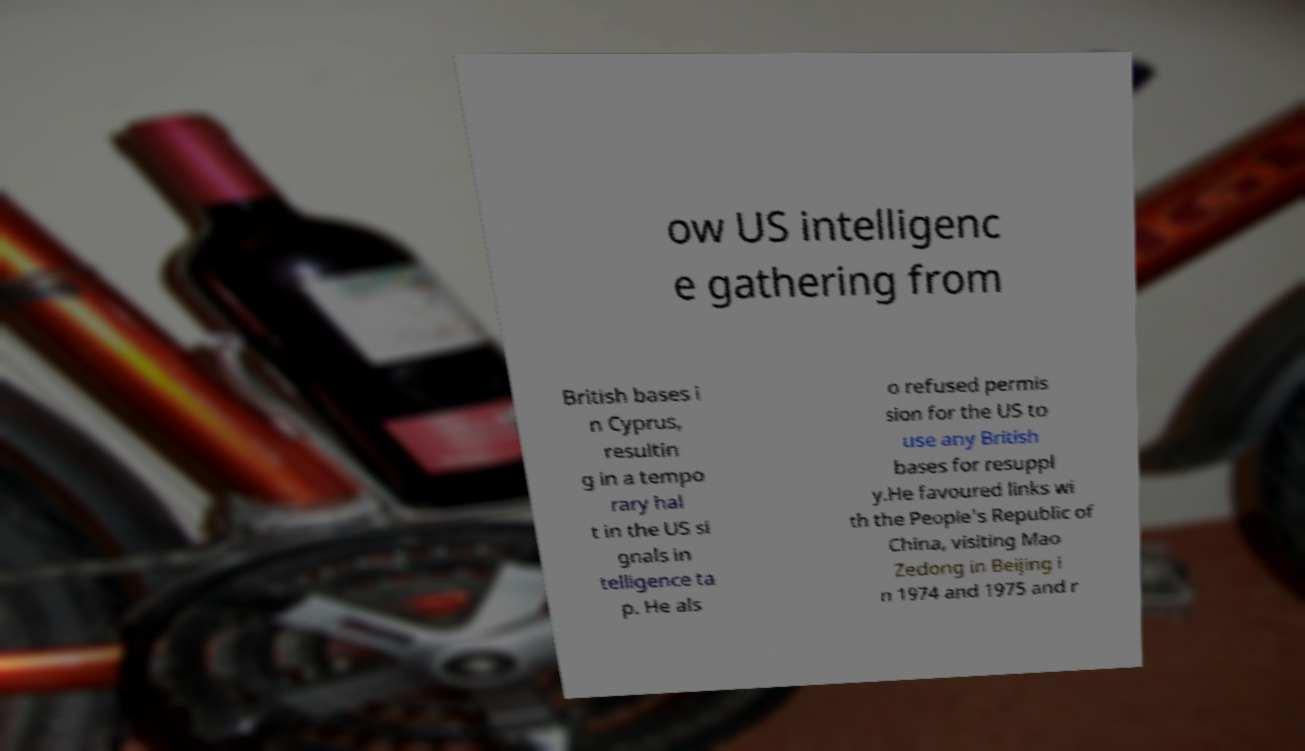For documentation purposes, I need the text within this image transcribed. Could you provide that? ow US intelligenc e gathering from British bases i n Cyprus, resultin g in a tempo rary hal t in the US si gnals in telligence ta p. He als o refused permis sion for the US to use any British bases for resuppl y.He favoured links wi th the People's Republic of China, visiting Mao Zedong in Beijing i n 1974 and 1975 and r 